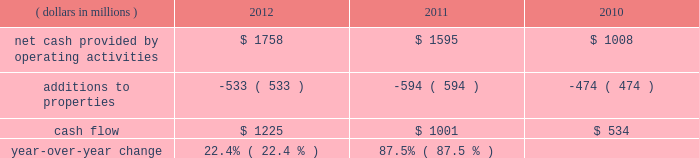We measure cash flow as net cash provided by operating activities reduced by expenditures for property additions .
We use this non-gaap financial measure of cash flow to focus management and investors on the amount of cash available for debt repayment , dividend distributions , acquisition opportunities , and share repurchases .
Our cash flow metric is reconciled to the most comparable gaap measure , as follows: .
Year-over-year change 22.4 % (  % ) 87.5 % (  % ) year-over-year changes in cash flow ( as defined ) were driven by improved performance in working capital resulting from the benefit derived from the pringles acquisition , as well as changes in the level of capital expenditures during the three-year period .
Investing activities our net cash used in investing activities for 2012 amounted to $ 3245 million , an increase of $ 2658 million compared with 2011 primarily attributable to the $ 2668 acquisition of pringles in capital spending in 2012 included investments in our supply chain infrastructure , and to support capacity requirements in certain markets , including pringles .
In addition , we continued the investment in our information technology infrastructure related to the reimplementation and upgrade of our sap platform .
Net cash used in investing activities of $ 587 million in 2011 increased by $ 122 million compared with 2010 , reflecting capital projects for our reimplementation and upgrade of our sap platform and investments in our supply chain .
Cash paid for additions to properties as a percentage of net sales has decreased to 3.8% ( 3.8 % ) in 2012 , from 4.5% ( 4.5 % ) in 2011 , which was an increase from 3.8% ( 3.8 % ) in financing activities in february 2013 , we issued $ 250 million of two-year floating-rate u.s .
Dollar notes , and $ 400 million of ten-year 2.75% ( 2.75 % ) u.s .
Dollar notes .
The proceeds from these notes will be used for general corporate purposes , including , together with cash on hand , repayment of the $ 750 million aggregate principal amount of our 4.25% ( 4.25 % ) u.s .
Dollar notes due march 2013 .
The floating-rate notes bear interest equal to three-month libor plus 23 basis points , subject to quarterly reset .
The notes contain customary covenants that limit the ability of kellogg company and its restricted subsidiaries ( as defined ) to incur certain liens or enter into certain sale and lease-back transactions , as well as a change of control provision .
Our net cash provided by financing activities was $ 1317 for 2012 , compared to net cash used in financing activities of $ 957 and $ 439 for 2011 and 2010 , respectively .
The increase in cash provided from financing activities in 2012 compared to 2011 and 2010 , was primarily due to the issuance of debt related to the acquisition of pringles .
Total debt was $ 7.9 billion at year-end 2012 and $ 6.0 billion at year-end 2011 .
In march 2012 , we entered into interest rate swaps on our $ 500 million five-year 1.875% ( 1.875 % ) fixed rate u.s .
Dollar notes due 2016 , $ 500 million ten-year 4.15% ( 4.15 % ) fixed rate u.s .
Dollar notes due 2019 and $ 500 million of our $ 750 million seven-year 4.45% ( 4.45 % ) fixed rate u.s .
Dollar notes due 2016 .
The interest rate swaps effectively converted these notes from their fixed rates to floating rate obligations through maturity .
In may 2012 , we issued $ 350 million of three-year 1.125% ( 1.125 % ) u.s .
Dollar notes , $ 400 million of five-year 1.75% ( 1.75 % ) u.s .
Dollar notes and $ 700 million of ten-year 3.125% ( 3.125 % ) u.s .
Dollar notes , resulting in aggregate net proceeds after debt discount of $ 1.442 billion .
The proceeds of these notes were used for general corporate purposes , including financing a portion of the acquisition of pringles .
In may 2012 , we issued cdn .
$ 300 million of two-year 2.10% ( 2.10 % ) fixed rate canadian dollar notes , using the proceeds from these notes for general corporate purposes , which included repayment of intercompany debt .
This repayment resulted in cash available to be used for a portion of the acquisition of pringles .
In december 2012 , we repaid $ 750 million five-year 5.125% ( 5.125 % ) u.s .
Dollar notes at maturity with commercial paper .
In february 2011 , we entered into interest rate swaps on $ 200 million of our $ 750 million seven-year 4.45% ( 4.45 % ) fixed rate u.s .
Dollar notes due 2016 .
The interest rate swaps effectively converted this portion of the notes from a fixed rate to a floating rate obligation through maturity .
In april 2011 , we repaid $ 945 million ten-year 6.60% ( 6.60 % ) u.s .
Dollar notes at maturity with commercial paper .
In may 2011 , we issued $ 400 million of seven-year 3.25% ( 3.25 % ) fixed rate u.s .
Dollar notes , using the proceeds of $ 397 million for general corporate purposes and repayment of commercial paper .
During 2011 , we entered into interest rate swaps with notional amounts totaling $ 400 million , which effectively converted these notes from a fixed rate to a floating rate obligation through maturity .
In november 2011 , we issued $ 500 million of five-year 1.875% ( 1.875 % ) fixed rate u .
Dollar notes , using the proceeds of $ 498 million for general corporate purposes and repayment of commercial paper .
During 2012 , we entered into interest rate swaps which effectively converted these notes from a fixed rate to a floating rate obligation through maturity .
In april 2010 , our board of directors approved a share repurchase program authorizing us to repurchase shares of our common stock amounting to $ 2.5 billion during 2010 through 2012 .
This three year authorization replaced previous share buyback programs which had authorized stock repurchases of up to $ 1.1 billion for 2010 and $ 650 million for 2009 .
Under this program , we repurchased approximately 1 million , 15 million and 21 million shares of common stock for $ 63 million , $ 793 million and $ 1.1 billion during 2012 , 2011 and 2010 , respectively .
In december 2012 , our board of directors approved a share repurchase program authorizing us to repurchase shares of our common stock amounting to $ 300 million during 2013 .
We paid quarterly dividends to shareholders totaling $ 1.74 per share in 2012 , $ 1.67 per share in 2011 and $ 1.56 per share in 2010 .
Total cash paid for dividends increased by 3.0% ( 3.0 % ) in 2012 and 3.4% ( 3.4 % ) in 2011 .
In march 2011 , we entered into an unsecured four- year credit agreement which allows us to borrow , on a revolving credit basis , up to $ 2.0 billion .
Our long-term debt agreements contain customary covenants that limit kellogg company and some of its subsidiaries from incurring certain liens or from entering into certain sale and lease-back transactions .
Some agreements also contain change in control provisions .
However , they do not contain acceleration of maturity clauses that are dependent on credit ratings .
A change in our credit ratings could limit our access to the u.s .
Short-term debt market and/or increase the cost of refinancing long-term debt in the future .
However , even under these circumstances , we would continue to have access to our four-year credit agreement , which expires in march 2015 .
This source of liquidity is unused and available on an unsecured basis , although we do not currently plan to use it .
Capital and credit markets , including commercial paper markets , continued to experience instability and disruption as the u.s .
And global economies underwent a period of extreme uncertainty .
Throughout this period of uncertainty , we continued to have access to the u.s. , european , and canadian commercial paper markets .
Our commercial paper and term debt credit ratings were not affected by the changes in the credit environment .
We monitor the financial strength of our third-party financial institutions , including those that hold our cash and cash equivalents as well as those who serve as counterparties to our credit facilities , our derivative financial instruments , and other arrangements .
We are in compliance with all covenants as of december 29 , 2012 .
We continue to believe that we will be able to meet our interest and principal repayment obligations and maintain our debt covenants for the foreseeable future , while still meeting our operational needs , including the pursuit of selected bolt-on acquisitions .
This will be accomplished through our strong cash flow , our short- term borrowings , and our maintenance of credit facilities on a global basis. .
What percent of net cash from operations is retain as cash flow? 
Computations: (1225 / 1758)
Answer: 0.69681. 